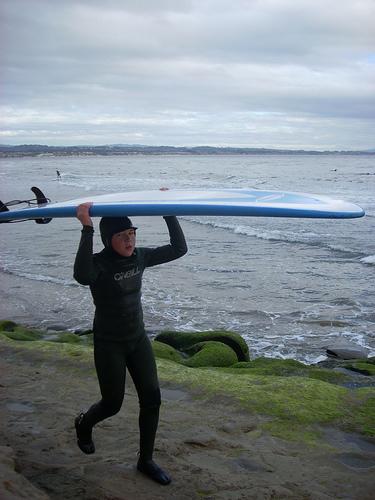What gender is this person?
Give a very brief answer. Male. What is the person carrying?
Quick response, please. Surfboard. What is the color of the surfboard?
Write a very short answer. Blue. Is this person wearing shoe?
Quick response, please. Yes. What is on the women's face?
Concise answer only. Nothing. 